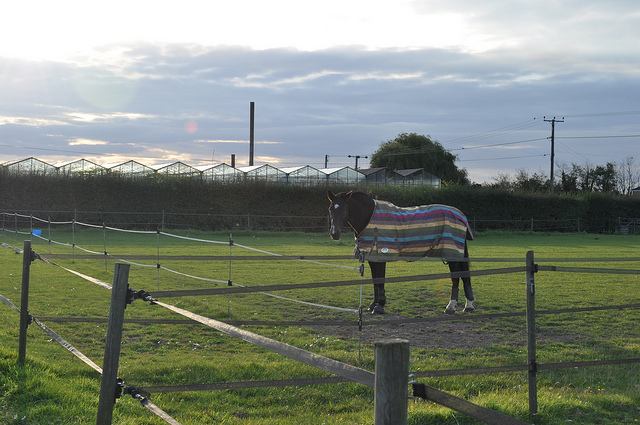<image>What is the black strip across the horse's face? It is unclear what the black strip across the horse's face is. It may be a bridle or there might be nothing. How do you call man jumping on a horse? It is not clear how you call a man jumping on a horse. It could refer to a cowboy or an equestrian. What is the black strip across the horse's face? I don't know what is the black strip across the horse's face. It can be a bridle, bit, harness, or nothing at all. How do you call man jumping on a horse? I don't know how you call a man jumping on a horse. It can be either 'cowboy' or 'equestrian'. 